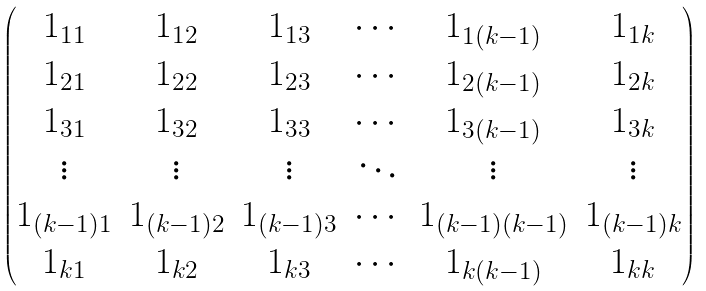<formula> <loc_0><loc_0><loc_500><loc_500>\begin{pmatrix} 1 _ { 1 1 } & 1 _ { 1 2 } & 1 _ { 1 3 } & \cdots & 1 _ { 1 ( k - 1 ) } & 1 _ { 1 k } \\ 1 _ { 2 1 } & 1 _ { 2 2 } & 1 _ { 2 3 } & \cdots & 1 _ { 2 ( k - 1 ) } & 1 _ { 2 k } \\ 1 _ { 3 1 } & 1 _ { 3 2 } & 1 _ { 3 3 } & \cdots & 1 _ { 3 ( k - 1 ) } & 1 _ { 3 k } \\ \vdots & \vdots & \vdots & \ddots & \vdots & \vdots \\ 1 _ { ( k - 1 ) 1 } & 1 _ { ( k - 1 ) 2 } & 1 _ { ( k - 1 ) 3 } & \cdots & 1 _ { ( k - 1 ) ( k - 1 ) } & 1 _ { ( k - 1 ) k } \\ 1 _ { k 1 } & 1 _ { k 2 } & 1 _ { k 3 } & \cdots & 1 _ { k ( k - 1 ) } & 1 _ { k k } \\ \end{pmatrix}</formula> 